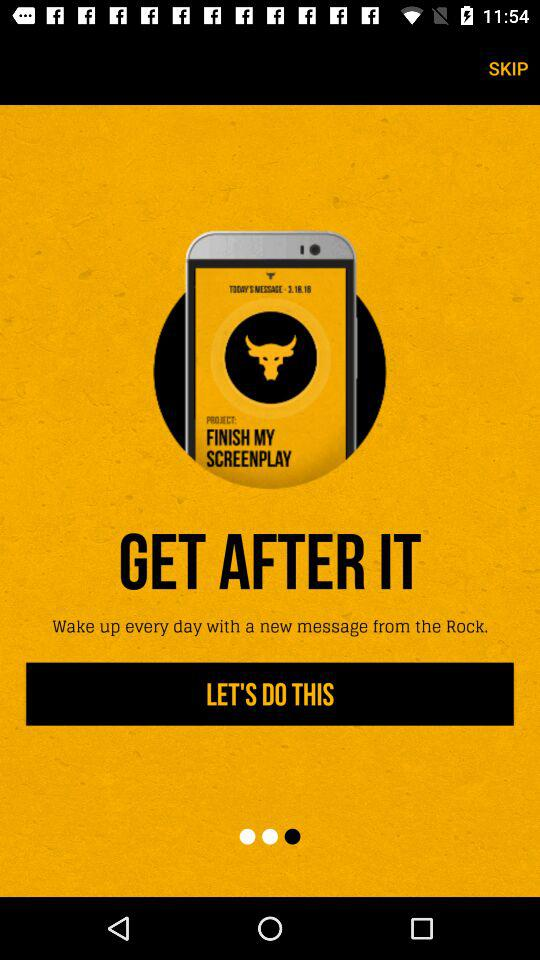What is the name of the application? The name of the application is "The Rock Clock". 